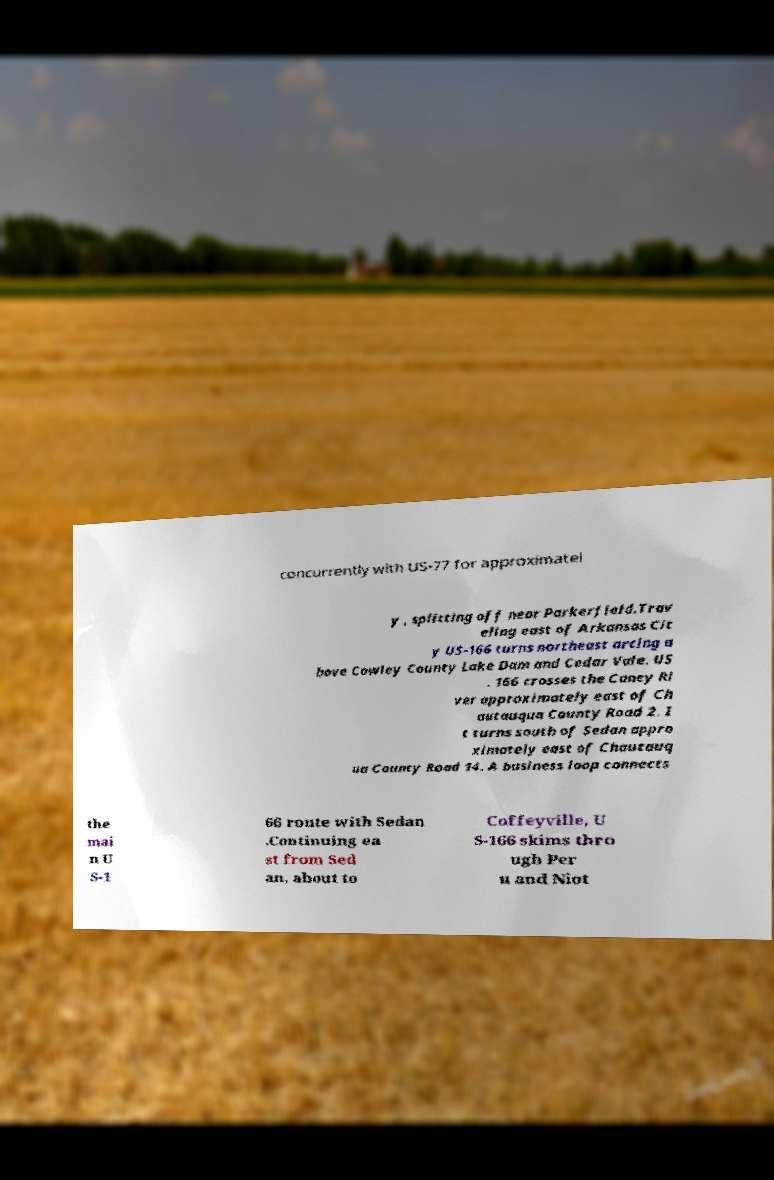I need the written content from this picture converted into text. Can you do that? concurrently with US-77 for approximatel y , splitting off near Parkerfield.Trav eling east of Arkansas Cit y US-166 turns northeast arcing a bove Cowley County Lake Dam and Cedar Vale. US . 166 crosses the Caney Ri ver approximately east of Ch autauqua County Road 2. I t turns south of Sedan appro ximately east of Chautauq ua County Road 14. A business loop connects the mai n U S-1 66 route with Sedan .Continuing ea st from Sed an, about to Coffeyville, U S-166 skims thro ugh Per u and Niot 